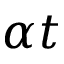<formula> <loc_0><loc_0><loc_500><loc_500>\alpha t</formula> 